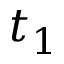<formula> <loc_0><loc_0><loc_500><loc_500>t _ { 1 }</formula> 